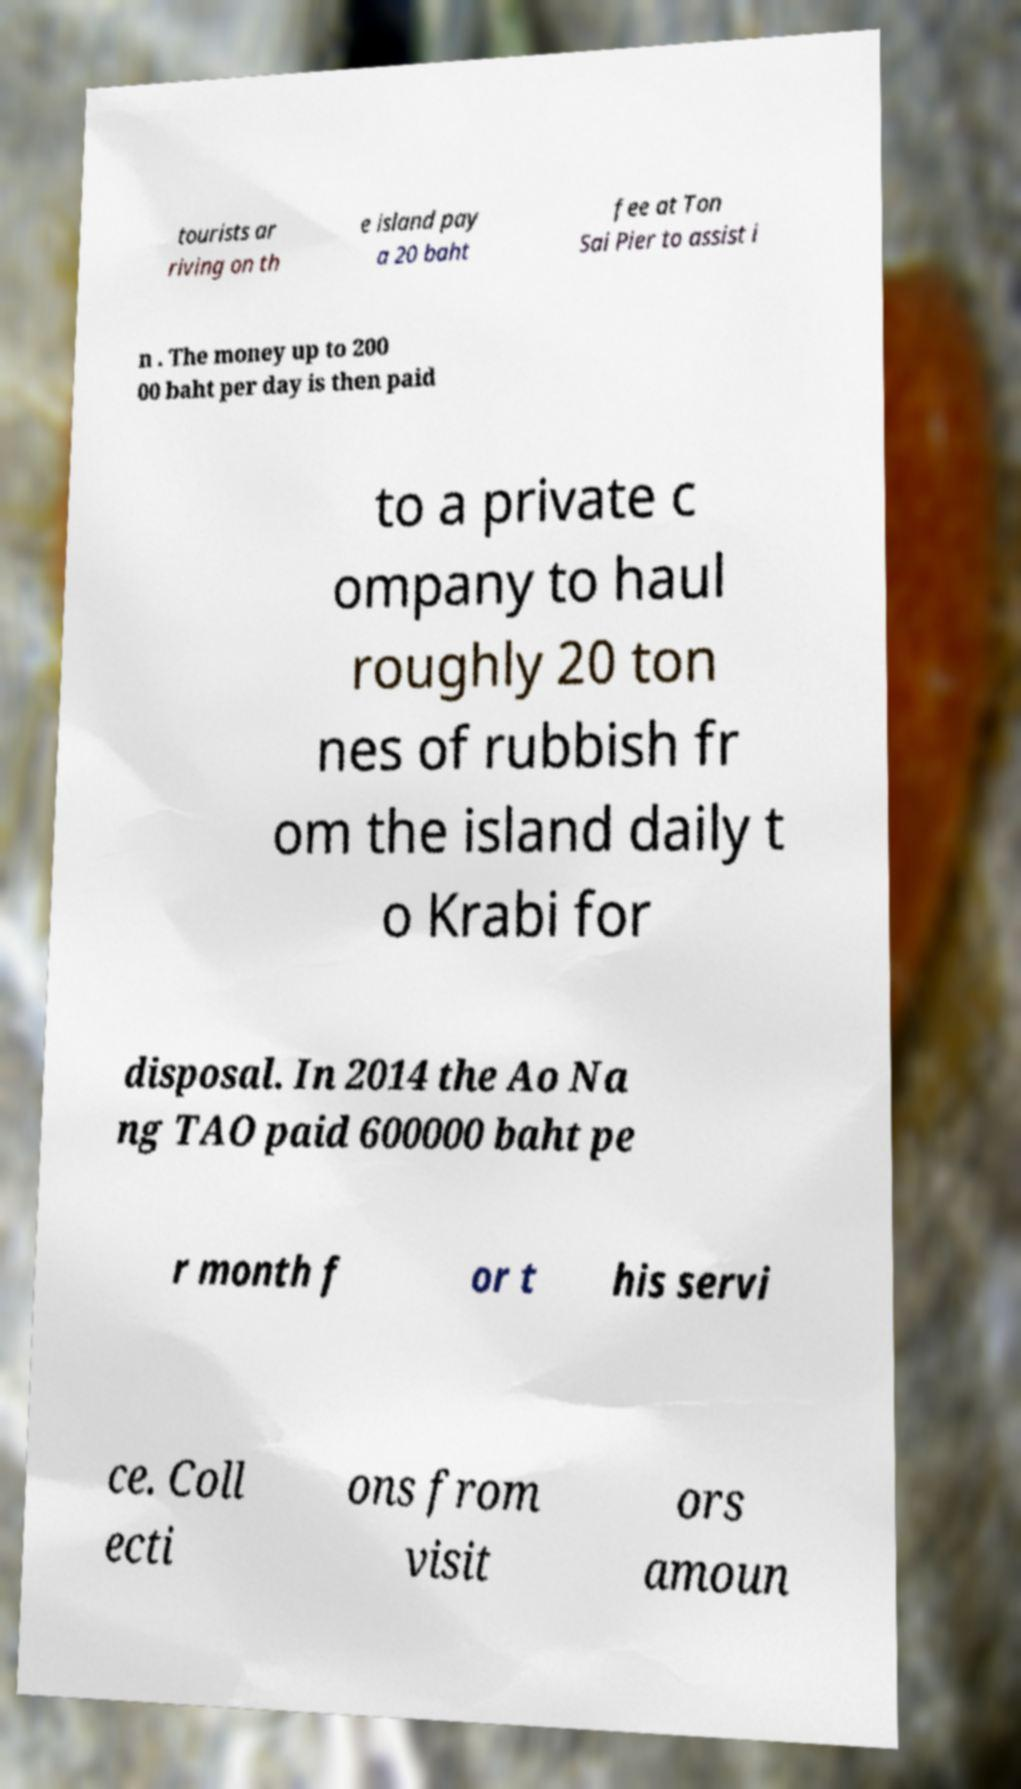Can you read and provide the text displayed in the image?This photo seems to have some interesting text. Can you extract and type it out for me? tourists ar riving on th e island pay a 20 baht fee at Ton Sai Pier to assist i n . The money up to 200 00 baht per day is then paid to a private c ompany to haul roughly 20 ton nes of rubbish fr om the island daily t o Krabi for disposal. In 2014 the Ao Na ng TAO paid 600000 baht pe r month f or t his servi ce. Coll ecti ons from visit ors amoun 